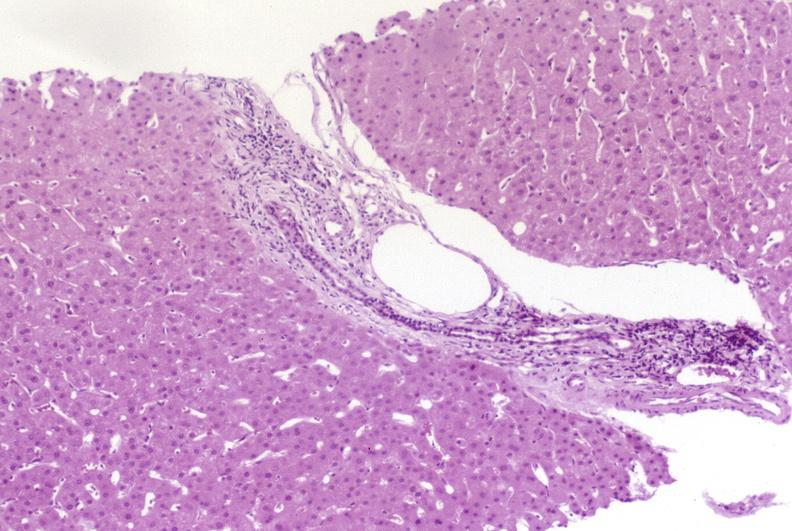what is present?
Answer the question using a single word or phrase. Hepatobiliary 